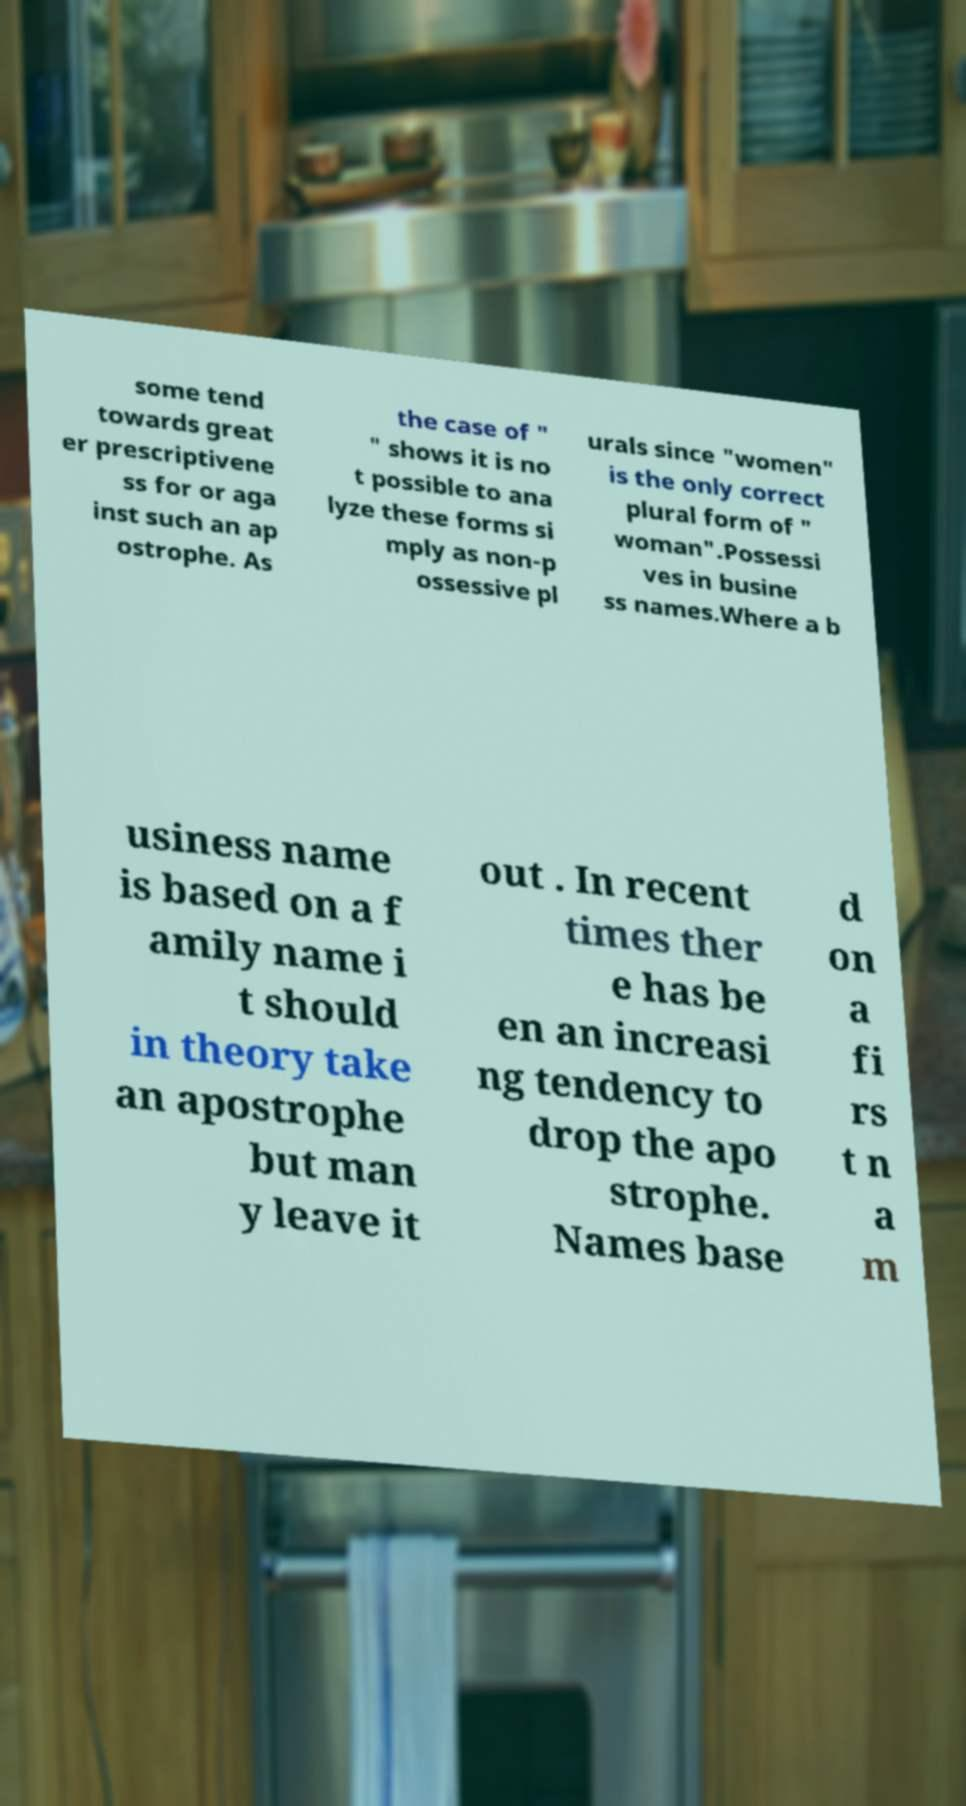I need the written content from this picture converted into text. Can you do that? some tend towards great er prescriptivene ss for or aga inst such an ap ostrophe. As the case of " " shows it is no t possible to ana lyze these forms si mply as non-p ossessive pl urals since "women" is the only correct plural form of " woman".Possessi ves in busine ss names.Where a b usiness name is based on a f amily name i t should in theory take an apostrophe but man y leave it out . In recent times ther e has be en an increasi ng tendency to drop the apo strophe. Names base d on a fi rs t n a m 